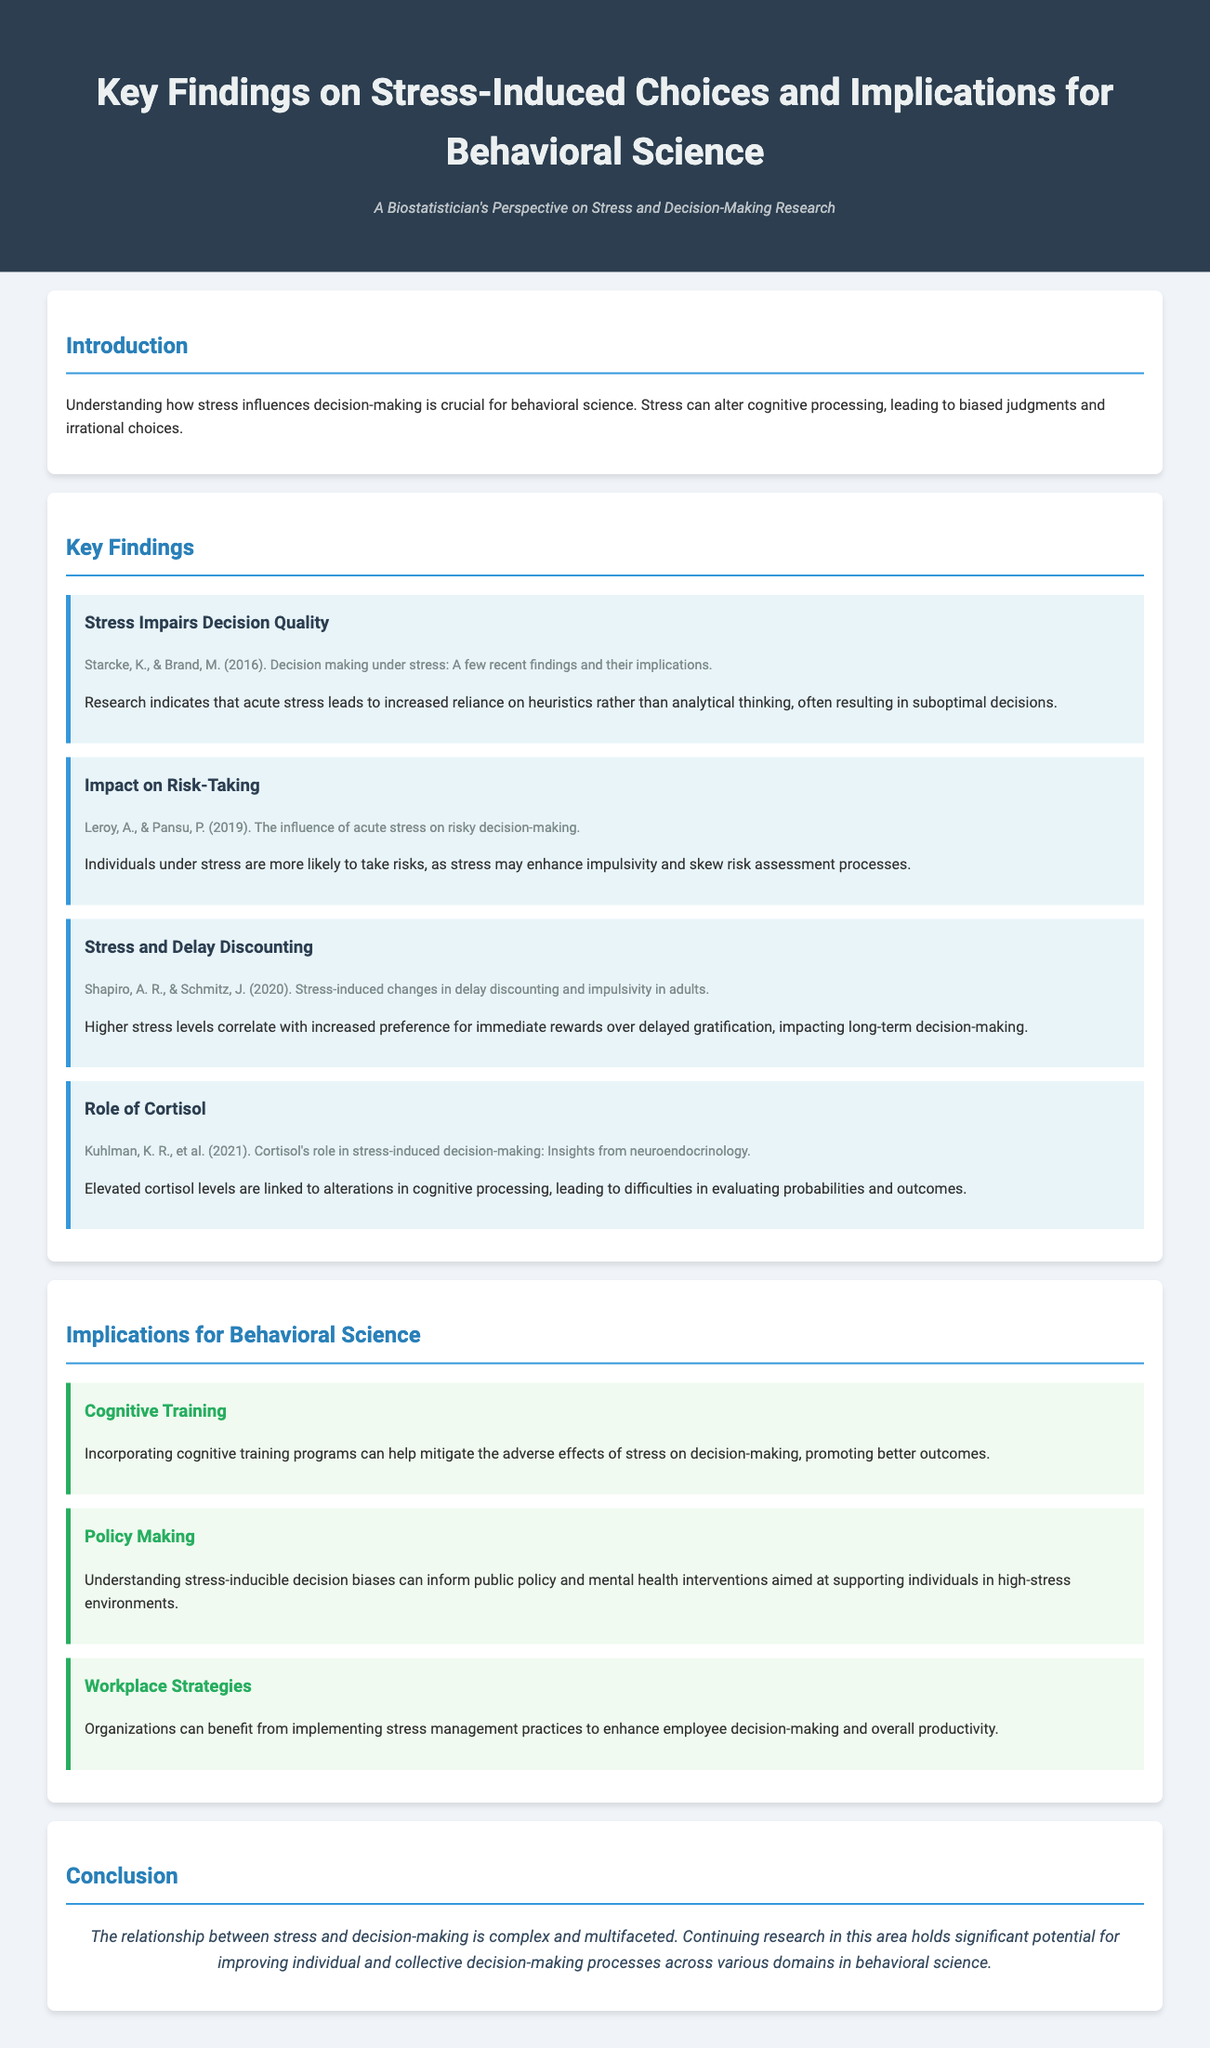What is the title of the document? The title of the document is found in the header section, which introduces the main subject of the study.
Answer: Key Findings on Stress-Induced Choices and Implications for Behavioral Science Who are the authors of the first study referenced? The author names for the first referenced study can be found within the key findings section of the document.
Answer: Starcke, K., & Brand, M What is one effect of acute stress mentioned in the document? The document states effects of stress under various findings, one of which is included in the summary of key findings.
Answer: Impairs decision quality Which hormone's role is discussed concerning decision-making? The document highlights a specific hormone that affects cognitive processing during stress, mentioned in the findings section.
Answer: Cortisol What does the document suggest as a strategy for organizations? The document implies specific strategies related to managing stress in workplaces that can enhance decision-making.
Answer: Stress management practices How does higher stress affect reward preference? The document outlines a specific effect of higher stress levels on decision-making concerning rewards.
Answer: Immediate rewards What cognitive intervention is proposed to mitigate stress effects? The findings suggest specific cognitive interventions to alleviate negative impacts of stress on decision-making processes.
Answer: Cognitive training What is one implication of understanding stress-inducible biases? The document presents various implications for behavioral science, one of which relates to public policy.
Answer: Inform public policy 